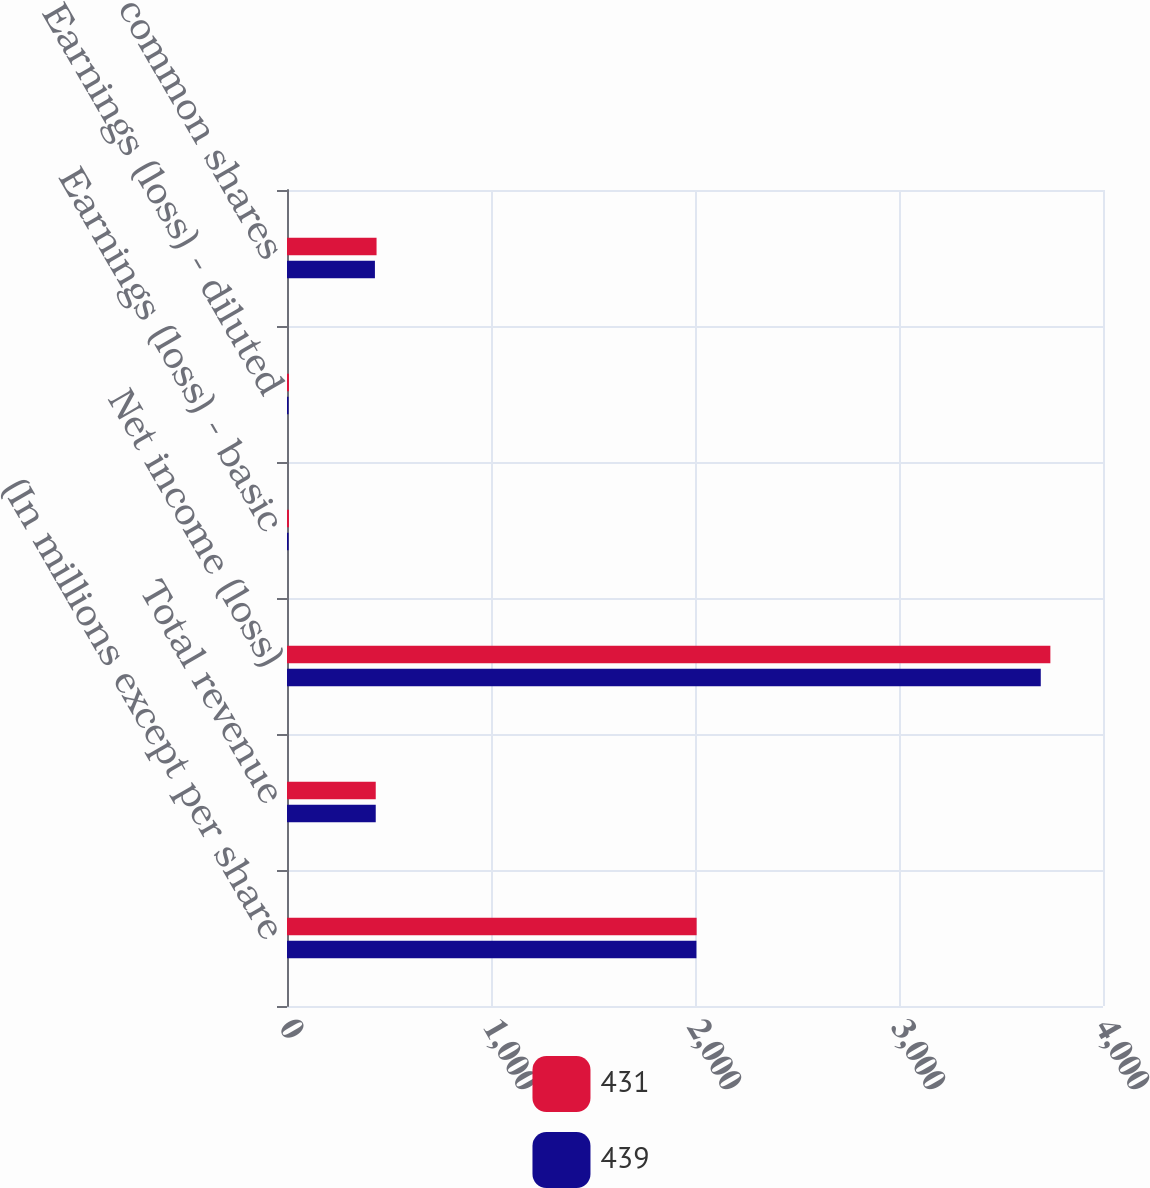Convert chart to OTSL. <chart><loc_0><loc_0><loc_500><loc_500><stacked_bar_chart><ecel><fcel>(In millions except per share<fcel>Total revenue<fcel>Net income (loss)<fcel>Earnings (loss) - basic<fcel>Earnings (loss) - diluted<fcel>Average common shares<nl><fcel>431<fcel>2008<fcel>435<fcel>3742<fcel>9.58<fcel>9.6<fcel>439<nl><fcel>439<fcel>2007<fcel>435<fcel>3695<fcel>7.66<fcel>7.55<fcel>431<nl></chart> 